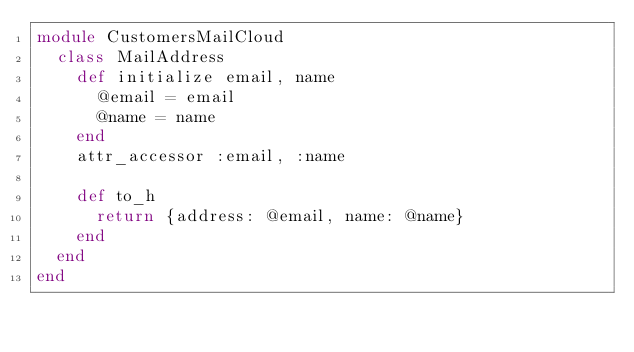<code> <loc_0><loc_0><loc_500><loc_500><_Ruby_>module CustomersMailCloud
  class MailAddress
    def initialize email, name
      @email = email
      @name = name
    end
    attr_accessor :email, :name

    def to_h
      return {address: @email, name: @name}
    end
  end
end</code> 